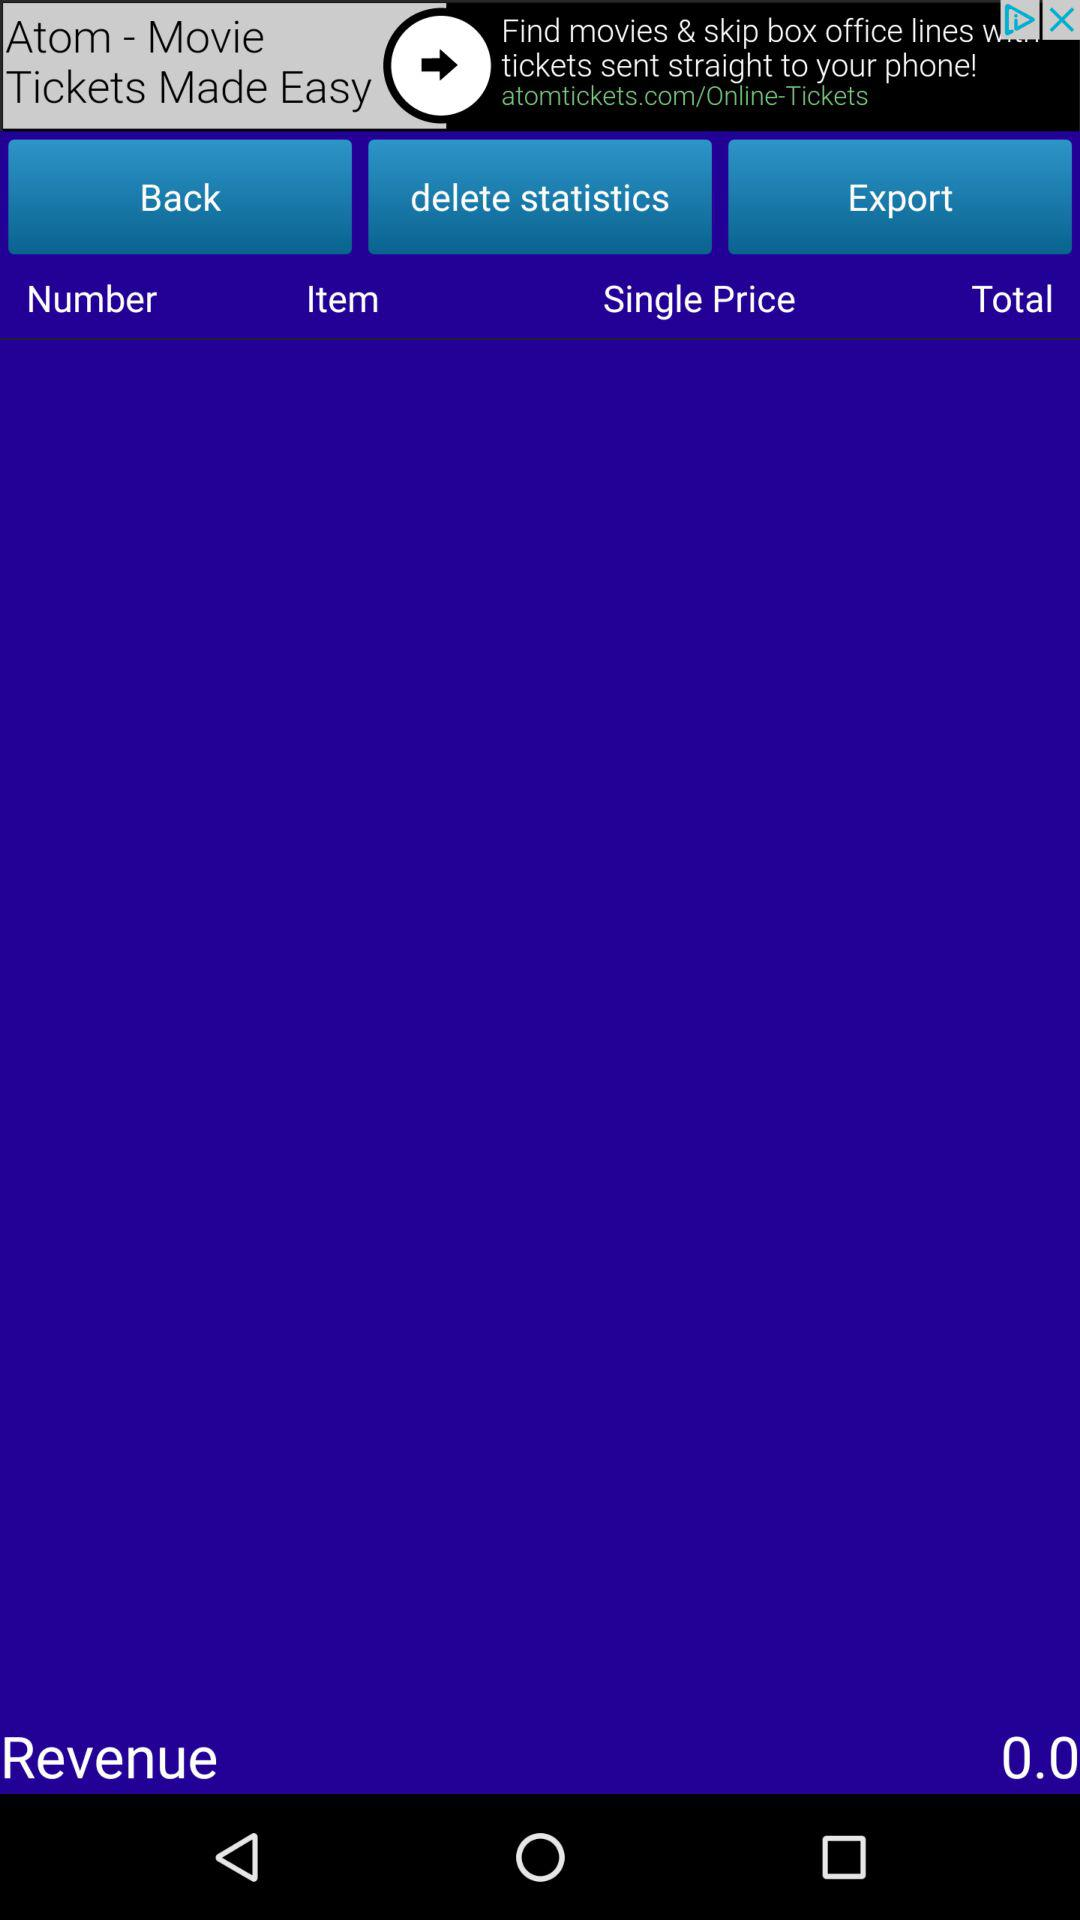What is the revenue? The revenue is 0.0. 